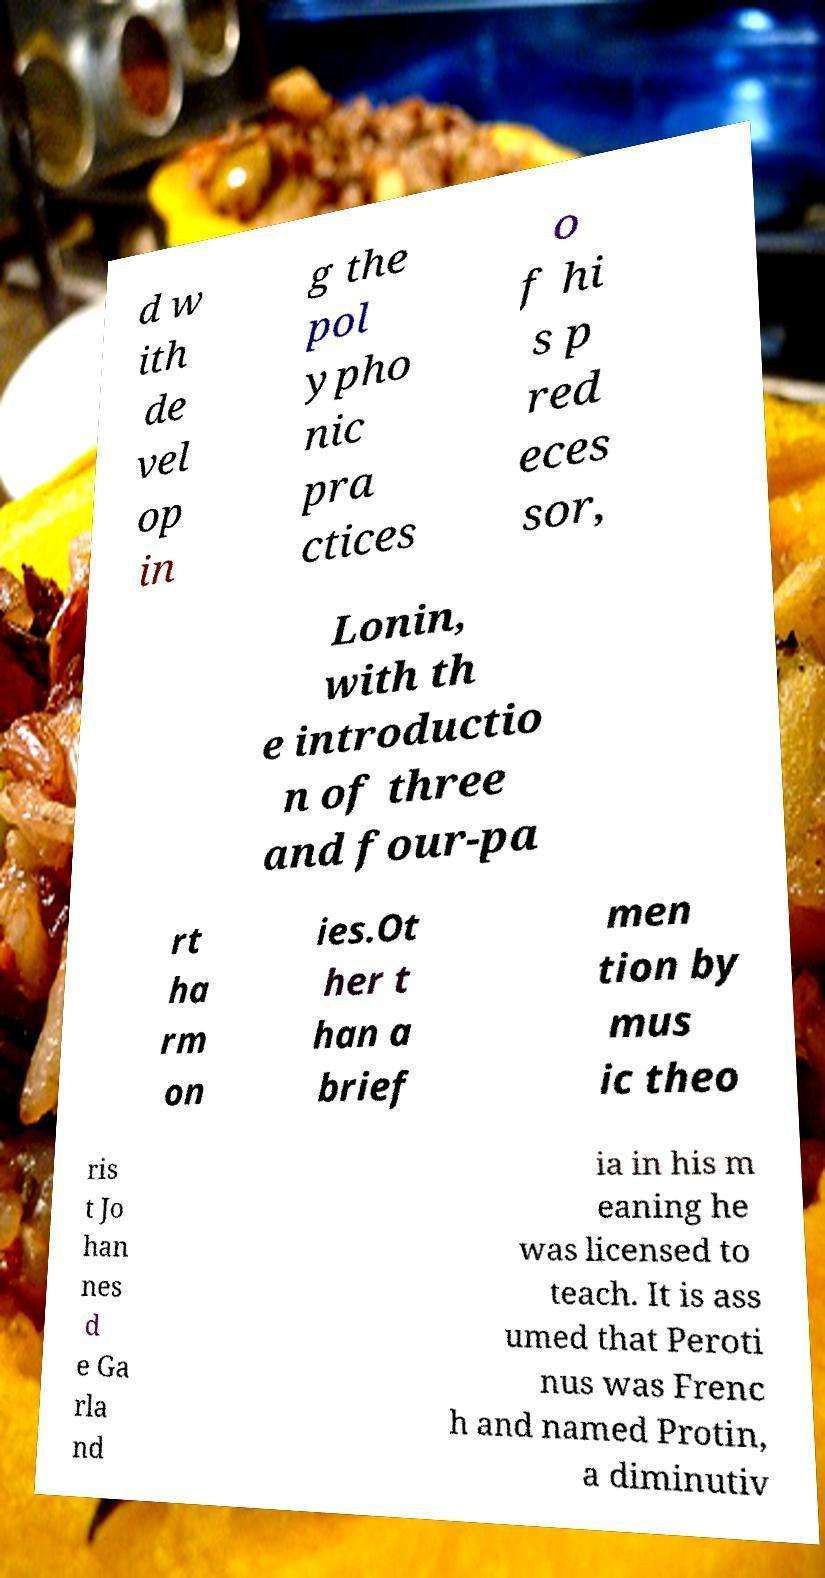Please identify and transcribe the text found in this image. d w ith de vel op in g the pol ypho nic pra ctices o f hi s p red eces sor, Lonin, with th e introductio n of three and four-pa rt ha rm on ies.Ot her t han a brief men tion by mus ic theo ris t Jo han nes d e Ga rla nd ia in his m eaning he was licensed to teach. It is ass umed that Peroti nus was Frenc h and named Protin, a diminutiv 